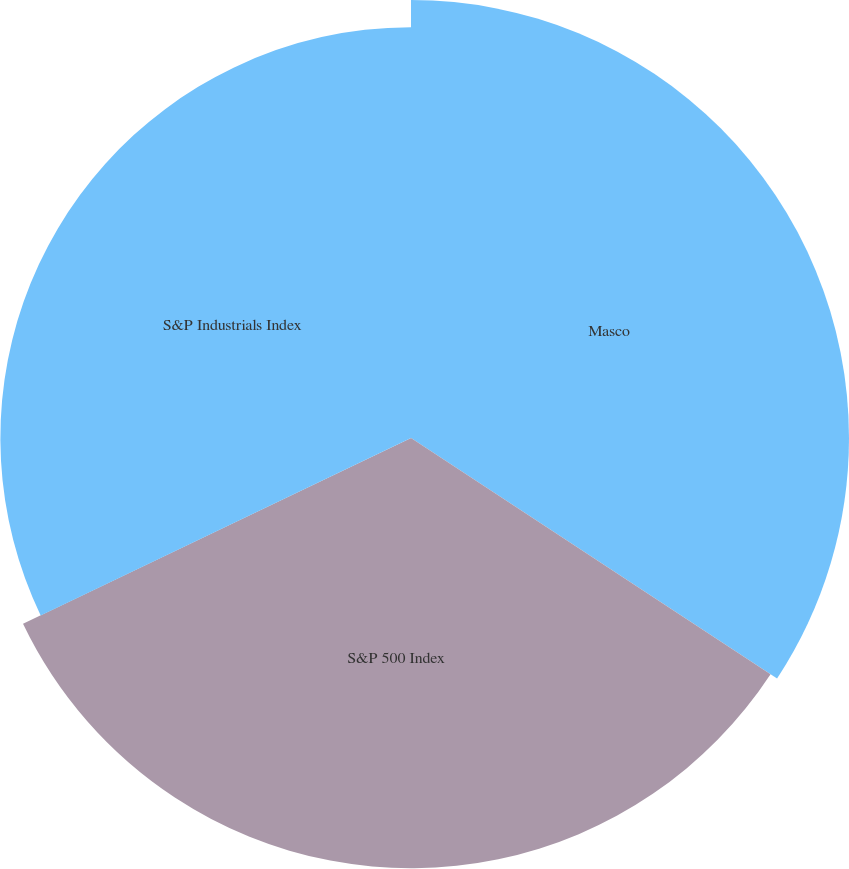<chart> <loc_0><loc_0><loc_500><loc_500><pie_chart><fcel>Masco<fcel>S&P 500 Index<fcel>S&P Industrials Index<nl><fcel>34.25%<fcel>33.64%<fcel>32.11%<nl></chart> 